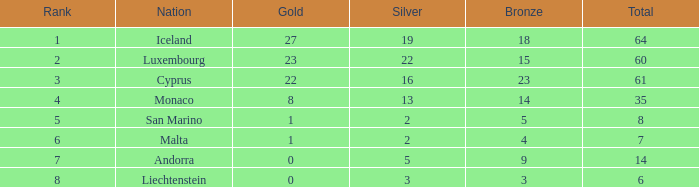How many golds for the nation with 14 total? 0.0. 